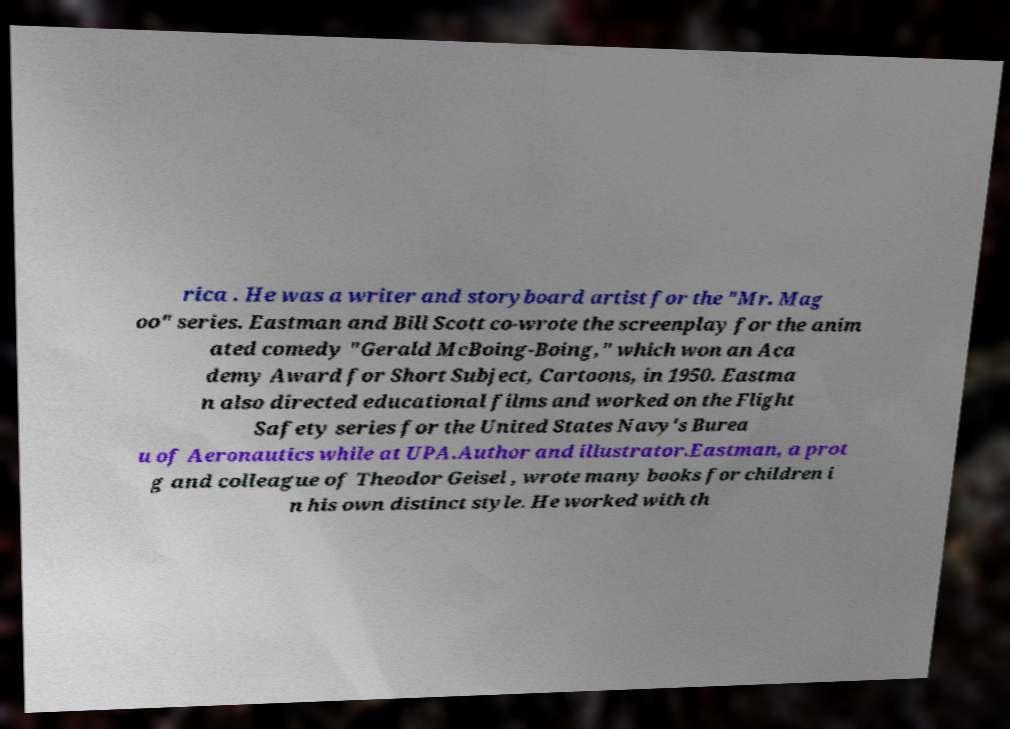What messages or text are displayed in this image? I need them in a readable, typed format. rica . He was a writer and storyboard artist for the "Mr. Mag oo" series. Eastman and Bill Scott co-wrote the screenplay for the anim ated comedy "Gerald McBoing-Boing," which won an Aca demy Award for Short Subject, Cartoons, in 1950. Eastma n also directed educational films and worked on the Flight Safety series for the United States Navy's Burea u of Aeronautics while at UPA.Author and illustrator.Eastman, a prot g and colleague of Theodor Geisel , wrote many books for children i n his own distinct style. He worked with th 